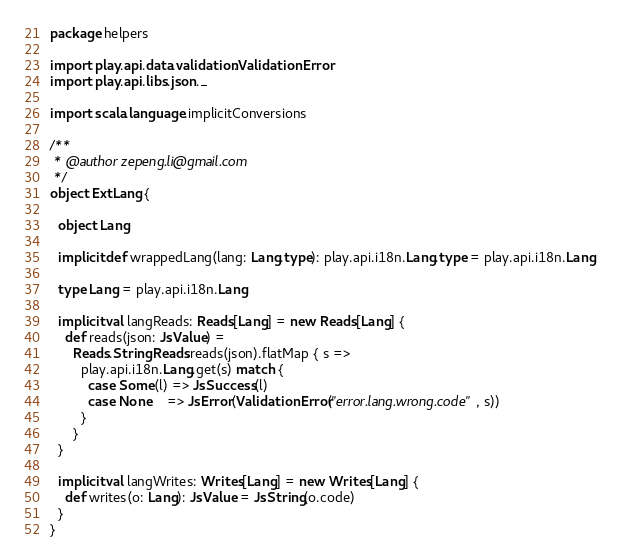<code> <loc_0><loc_0><loc_500><loc_500><_Scala_>package helpers

import play.api.data.validation.ValidationError
import play.api.libs.json._

import scala.language.implicitConversions

/**
 * @author zepeng.li@gmail.com
 */
object ExtLang {

  object Lang

  implicit def wrappedLang(lang: Lang.type): play.api.i18n.Lang.type = play.api.i18n.Lang

  type Lang = play.api.i18n.Lang

  implicit val langReads: Reads[Lang] = new Reads[Lang] {
    def reads(json: JsValue) =
      Reads.StringReads.reads(json).flatMap { s =>
        play.api.i18n.Lang.get(s) match {
          case Some(l) => JsSuccess(l)
          case None    => JsError(ValidationError("error.lang.wrong.code", s))
        }
      }
  }

  implicit val langWrites: Writes[Lang] = new Writes[Lang] {
    def writes(o: Lang): JsValue = JsString(o.code)
  }
}</code> 